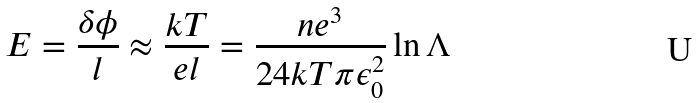Convert formula to latex. <formula><loc_0><loc_0><loc_500><loc_500>E = \frac { \delta \phi } { l } \approx \frac { k T } { e l } = \frac { n e ^ { 3 } } { 2 4 k T \pi \epsilon _ { 0 } ^ { 2 } } \ln \Lambda</formula> 